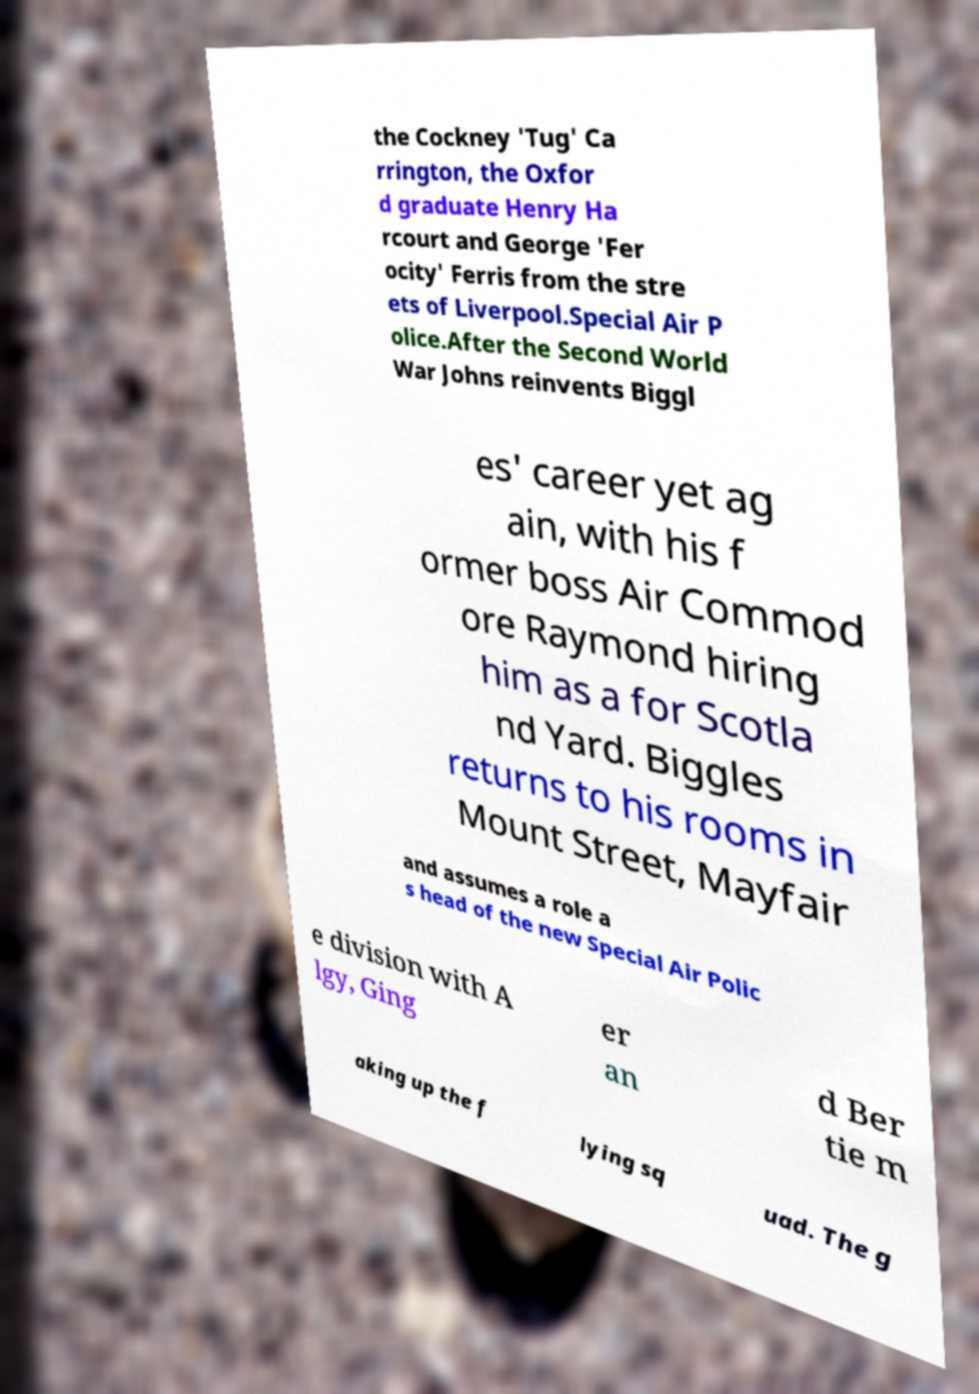For documentation purposes, I need the text within this image transcribed. Could you provide that? the Cockney 'Tug' Ca rrington, the Oxfor d graduate Henry Ha rcourt and George 'Fer ocity' Ferris from the stre ets of Liverpool.Special Air P olice.After the Second World War Johns reinvents Biggl es' career yet ag ain, with his f ormer boss Air Commod ore Raymond hiring him as a for Scotla nd Yard. Biggles returns to his rooms in Mount Street, Mayfair and assumes a role a s head of the new Special Air Polic e division with A lgy, Ging er an d Ber tie m aking up the f lying sq uad. The g 